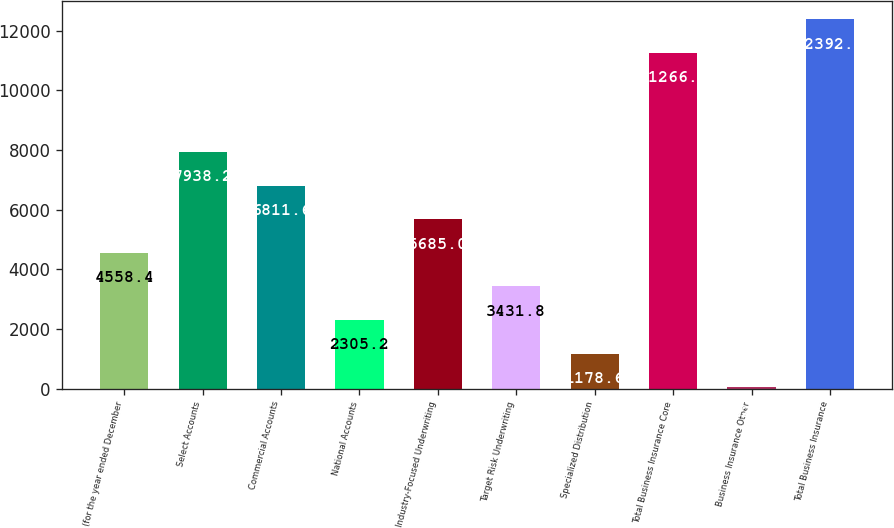<chart> <loc_0><loc_0><loc_500><loc_500><bar_chart><fcel>(for the year ended December<fcel>Select Accounts<fcel>Commercial Accounts<fcel>National Accounts<fcel>Industry-Focused Underwriting<fcel>Target Risk Underwriting<fcel>Specialized Distribution<fcel>Total Business Insurance Core<fcel>Business Insurance Other<fcel>Total Business Insurance<nl><fcel>4558.4<fcel>7938.2<fcel>6811.6<fcel>2305.2<fcel>5685<fcel>3431.8<fcel>1178.6<fcel>11266<fcel>52<fcel>12392.6<nl></chart> 